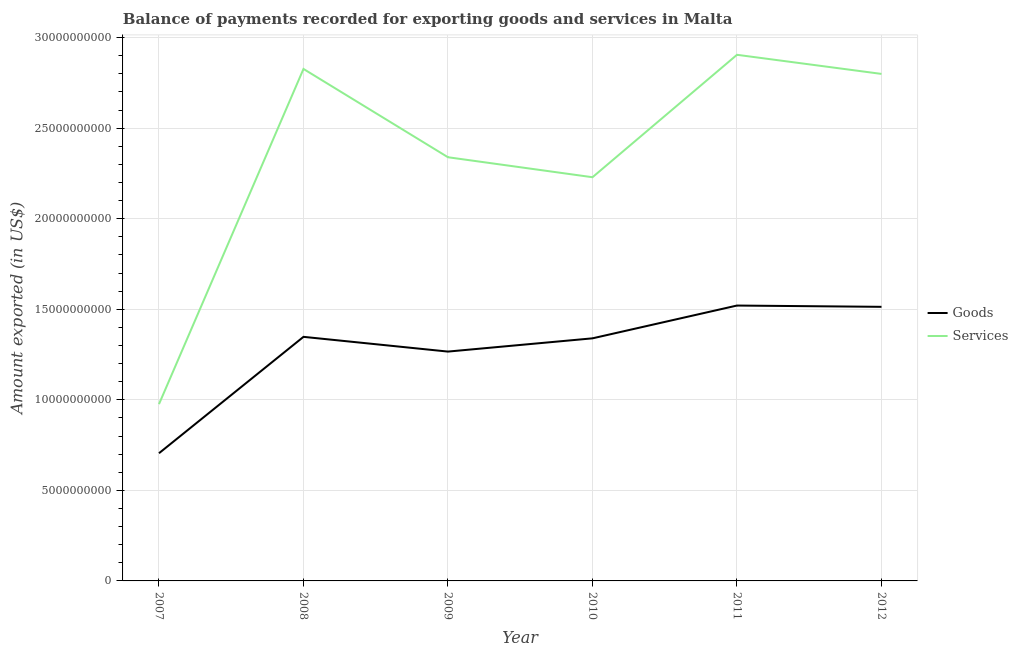Is the number of lines equal to the number of legend labels?
Offer a terse response. Yes. What is the amount of goods exported in 2011?
Provide a short and direct response. 1.52e+1. Across all years, what is the maximum amount of services exported?
Provide a short and direct response. 2.91e+1. Across all years, what is the minimum amount of services exported?
Make the answer very short. 9.76e+09. In which year was the amount of goods exported minimum?
Provide a succinct answer. 2007. What is the total amount of goods exported in the graph?
Provide a short and direct response. 7.69e+1. What is the difference between the amount of goods exported in 2007 and that in 2012?
Keep it short and to the point. -8.08e+09. What is the difference between the amount of services exported in 2012 and the amount of goods exported in 2009?
Offer a terse response. 1.53e+1. What is the average amount of goods exported per year?
Keep it short and to the point. 1.28e+1. In the year 2010, what is the difference between the amount of goods exported and amount of services exported?
Provide a succinct answer. -8.90e+09. What is the ratio of the amount of services exported in 2008 to that in 2010?
Your answer should be compact. 1.27. What is the difference between the highest and the second highest amount of goods exported?
Make the answer very short. 7.08e+07. What is the difference between the highest and the lowest amount of goods exported?
Provide a succinct answer. 8.16e+09. In how many years, is the amount of goods exported greater than the average amount of goods exported taken over all years?
Offer a very short reply. 4. Is the sum of the amount of goods exported in 2008 and 2010 greater than the maximum amount of services exported across all years?
Give a very brief answer. No. Does the amount of services exported monotonically increase over the years?
Offer a very short reply. No. How many lines are there?
Provide a succinct answer. 2. What is the difference between two consecutive major ticks on the Y-axis?
Your answer should be very brief. 5.00e+09. Does the graph contain grids?
Ensure brevity in your answer.  Yes. How many legend labels are there?
Make the answer very short. 2. How are the legend labels stacked?
Your answer should be compact. Vertical. What is the title of the graph?
Ensure brevity in your answer.  Balance of payments recorded for exporting goods and services in Malta. Does "External balance on goods" appear as one of the legend labels in the graph?
Provide a succinct answer. No. What is the label or title of the X-axis?
Provide a short and direct response. Year. What is the label or title of the Y-axis?
Keep it short and to the point. Amount exported (in US$). What is the Amount exported (in US$) in Goods in 2007?
Your response must be concise. 7.05e+09. What is the Amount exported (in US$) of Services in 2007?
Offer a very short reply. 9.76e+09. What is the Amount exported (in US$) of Goods in 2008?
Make the answer very short. 1.35e+1. What is the Amount exported (in US$) of Services in 2008?
Offer a very short reply. 2.83e+1. What is the Amount exported (in US$) in Goods in 2009?
Offer a very short reply. 1.27e+1. What is the Amount exported (in US$) in Services in 2009?
Your answer should be very brief. 2.34e+1. What is the Amount exported (in US$) of Goods in 2010?
Provide a short and direct response. 1.34e+1. What is the Amount exported (in US$) of Services in 2010?
Offer a terse response. 2.23e+1. What is the Amount exported (in US$) of Goods in 2011?
Offer a terse response. 1.52e+1. What is the Amount exported (in US$) in Services in 2011?
Provide a succinct answer. 2.91e+1. What is the Amount exported (in US$) of Goods in 2012?
Provide a short and direct response. 1.51e+1. What is the Amount exported (in US$) in Services in 2012?
Keep it short and to the point. 2.80e+1. Across all years, what is the maximum Amount exported (in US$) in Goods?
Make the answer very short. 1.52e+1. Across all years, what is the maximum Amount exported (in US$) in Services?
Provide a succinct answer. 2.91e+1. Across all years, what is the minimum Amount exported (in US$) of Goods?
Provide a succinct answer. 7.05e+09. Across all years, what is the minimum Amount exported (in US$) in Services?
Your response must be concise. 9.76e+09. What is the total Amount exported (in US$) of Goods in the graph?
Offer a terse response. 7.69e+1. What is the total Amount exported (in US$) in Services in the graph?
Make the answer very short. 1.41e+11. What is the difference between the Amount exported (in US$) in Goods in 2007 and that in 2008?
Offer a very short reply. -6.43e+09. What is the difference between the Amount exported (in US$) of Services in 2007 and that in 2008?
Keep it short and to the point. -1.85e+1. What is the difference between the Amount exported (in US$) in Goods in 2007 and that in 2009?
Your answer should be very brief. -5.61e+09. What is the difference between the Amount exported (in US$) in Services in 2007 and that in 2009?
Offer a very short reply. -1.36e+1. What is the difference between the Amount exported (in US$) in Goods in 2007 and that in 2010?
Keep it short and to the point. -6.34e+09. What is the difference between the Amount exported (in US$) of Services in 2007 and that in 2010?
Offer a very short reply. -1.25e+1. What is the difference between the Amount exported (in US$) of Goods in 2007 and that in 2011?
Your answer should be compact. -8.16e+09. What is the difference between the Amount exported (in US$) in Services in 2007 and that in 2011?
Offer a terse response. -1.93e+1. What is the difference between the Amount exported (in US$) of Goods in 2007 and that in 2012?
Ensure brevity in your answer.  -8.08e+09. What is the difference between the Amount exported (in US$) in Services in 2007 and that in 2012?
Provide a succinct answer. -1.82e+1. What is the difference between the Amount exported (in US$) of Goods in 2008 and that in 2009?
Give a very brief answer. 8.14e+08. What is the difference between the Amount exported (in US$) of Services in 2008 and that in 2009?
Your response must be concise. 4.88e+09. What is the difference between the Amount exported (in US$) in Goods in 2008 and that in 2010?
Your answer should be very brief. 8.22e+07. What is the difference between the Amount exported (in US$) of Services in 2008 and that in 2010?
Offer a terse response. 5.98e+09. What is the difference between the Amount exported (in US$) in Goods in 2008 and that in 2011?
Make the answer very short. -1.73e+09. What is the difference between the Amount exported (in US$) in Services in 2008 and that in 2011?
Offer a terse response. -7.81e+08. What is the difference between the Amount exported (in US$) in Goods in 2008 and that in 2012?
Offer a terse response. -1.66e+09. What is the difference between the Amount exported (in US$) of Services in 2008 and that in 2012?
Ensure brevity in your answer.  2.75e+08. What is the difference between the Amount exported (in US$) of Goods in 2009 and that in 2010?
Offer a very short reply. -7.32e+08. What is the difference between the Amount exported (in US$) of Services in 2009 and that in 2010?
Make the answer very short. 1.10e+09. What is the difference between the Amount exported (in US$) in Goods in 2009 and that in 2011?
Your answer should be very brief. -2.54e+09. What is the difference between the Amount exported (in US$) in Services in 2009 and that in 2011?
Ensure brevity in your answer.  -5.66e+09. What is the difference between the Amount exported (in US$) in Goods in 2009 and that in 2012?
Provide a succinct answer. -2.47e+09. What is the difference between the Amount exported (in US$) of Services in 2009 and that in 2012?
Give a very brief answer. -4.60e+09. What is the difference between the Amount exported (in US$) of Goods in 2010 and that in 2011?
Provide a short and direct response. -1.81e+09. What is the difference between the Amount exported (in US$) in Services in 2010 and that in 2011?
Ensure brevity in your answer.  -6.76e+09. What is the difference between the Amount exported (in US$) of Goods in 2010 and that in 2012?
Your answer should be very brief. -1.74e+09. What is the difference between the Amount exported (in US$) of Services in 2010 and that in 2012?
Your answer should be compact. -5.71e+09. What is the difference between the Amount exported (in US$) in Goods in 2011 and that in 2012?
Offer a terse response. 7.08e+07. What is the difference between the Amount exported (in US$) in Services in 2011 and that in 2012?
Offer a terse response. 1.06e+09. What is the difference between the Amount exported (in US$) in Goods in 2007 and the Amount exported (in US$) in Services in 2008?
Give a very brief answer. -2.12e+1. What is the difference between the Amount exported (in US$) of Goods in 2007 and the Amount exported (in US$) of Services in 2009?
Your answer should be very brief. -1.63e+1. What is the difference between the Amount exported (in US$) of Goods in 2007 and the Amount exported (in US$) of Services in 2010?
Give a very brief answer. -1.52e+1. What is the difference between the Amount exported (in US$) in Goods in 2007 and the Amount exported (in US$) in Services in 2011?
Give a very brief answer. -2.20e+1. What is the difference between the Amount exported (in US$) in Goods in 2007 and the Amount exported (in US$) in Services in 2012?
Make the answer very short. -2.09e+1. What is the difference between the Amount exported (in US$) of Goods in 2008 and the Amount exported (in US$) of Services in 2009?
Offer a terse response. -9.92e+09. What is the difference between the Amount exported (in US$) of Goods in 2008 and the Amount exported (in US$) of Services in 2010?
Make the answer very short. -8.81e+09. What is the difference between the Amount exported (in US$) in Goods in 2008 and the Amount exported (in US$) in Services in 2011?
Give a very brief answer. -1.56e+1. What is the difference between the Amount exported (in US$) in Goods in 2008 and the Amount exported (in US$) in Services in 2012?
Offer a very short reply. -1.45e+1. What is the difference between the Amount exported (in US$) in Goods in 2009 and the Amount exported (in US$) in Services in 2010?
Make the answer very short. -9.63e+09. What is the difference between the Amount exported (in US$) of Goods in 2009 and the Amount exported (in US$) of Services in 2011?
Make the answer very short. -1.64e+1. What is the difference between the Amount exported (in US$) in Goods in 2009 and the Amount exported (in US$) in Services in 2012?
Keep it short and to the point. -1.53e+1. What is the difference between the Amount exported (in US$) in Goods in 2010 and the Amount exported (in US$) in Services in 2011?
Make the answer very short. -1.57e+1. What is the difference between the Amount exported (in US$) in Goods in 2010 and the Amount exported (in US$) in Services in 2012?
Your response must be concise. -1.46e+1. What is the difference between the Amount exported (in US$) in Goods in 2011 and the Amount exported (in US$) in Services in 2012?
Keep it short and to the point. -1.28e+1. What is the average Amount exported (in US$) in Goods per year?
Make the answer very short. 1.28e+1. What is the average Amount exported (in US$) in Services per year?
Offer a terse response. 2.35e+1. In the year 2007, what is the difference between the Amount exported (in US$) in Goods and Amount exported (in US$) in Services?
Provide a short and direct response. -2.71e+09. In the year 2008, what is the difference between the Amount exported (in US$) of Goods and Amount exported (in US$) of Services?
Your answer should be compact. -1.48e+1. In the year 2009, what is the difference between the Amount exported (in US$) of Goods and Amount exported (in US$) of Services?
Offer a terse response. -1.07e+1. In the year 2010, what is the difference between the Amount exported (in US$) of Goods and Amount exported (in US$) of Services?
Offer a very short reply. -8.90e+09. In the year 2011, what is the difference between the Amount exported (in US$) of Goods and Amount exported (in US$) of Services?
Offer a very short reply. -1.38e+1. In the year 2012, what is the difference between the Amount exported (in US$) in Goods and Amount exported (in US$) in Services?
Make the answer very short. -1.29e+1. What is the ratio of the Amount exported (in US$) in Goods in 2007 to that in 2008?
Your response must be concise. 0.52. What is the ratio of the Amount exported (in US$) in Services in 2007 to that in 2008?
Keep it short and to the point. 0.35. What is the ratio of the Amount exported (in US$) in Goods in 2007 to that in 2009?
Your response must be concise. 0.56. What is the ratio of the Amount exported (in US$) of Services in 2007 to that in 2009?
Provide a succinct answer. 0.42. What is the ratio of the Amount exported (in US$) in Goods in 2007 to that in 2010?
Offer a very short reply. 0.53. What is the ratio of the Amount exported (in US$) in Services in 2007 to that in 2010?
Your answer should be compact. 0.44. What is the ratio of the Amount exported (in US$) in Goods in 2007 to that in 2011?
Your answer should be very brief. 0.46. What is the ratio of the Amount exported (in US$) of Services in 2007 to that in 2011?
Provide a short and direct response. 0.34. What is the ratio of the Amount exported (in US$) in Goods in 2007 to that in 2012?
Ensure brevity in your answer.  0.47. What is the ratio of the Amount exported (in US$) in Services in 2007 to that in 2012?
Keep it short and to the point. 0.35. What is the ratio of the Amount exported (in US$) of Goods in 2008 to that in 2009?
Your answer should be very brief. 1.06. What is the ratio of the Amount exported (in US$) in Services in 2008 to that in 2009?
Make the answer very short. 1.21. What is the ratio of the Amount exported (in US$) in Goods in 2008 to that in 2010?
Keep it short and to the point. 1.01. What is the ratio of the Amount exported (in US$) of Services in 2008 to that in 2010?
Offer a terse response. 1.27. What is the ratio of the Amount exported (in US$) of Goods in 2008 to that in 2011?
Make the answer very short. 0.89. What is the ratio of the Amount exported (in US$) in Services in 2008 to that in 2011?
Offer a very short reply. 0.97. What is the ratio of the Amount exported (in US$) in Goods in 2008 to that in 2012?
Your answer should be very brief. 0.89. What is the ratio of the Amount exported (in US$) of Services in 2008 to that in 2012?
Your answer should be very brief. 1.01. What is the ratio of the Amount exported (in US$) of Goods in 2009 to that in 2010?
Give a very brief answer. 0.95. What is the ratio of the Amount exported (in US$) in Services in 2009 to that in 2010?
Offer a terse response. 1.05. What is the ratio of the Amount exported (in US$) of Goods in 2009 to that in 2011?
Your answer should be compact. 0.83. What is the ratio of the Amount exported (in US$) of Services in 2009 to that in 2011?
Your response must be concise. 0.81. What is the ratio of the Amount exported (in US$) of Goods in 2009 to that in 2012?
Offer a very short reply. 0.84. What is the ratio of the Amount exported (in US$) in Services in 2009 to that in 2012?
Give a very brief answer. 0.84. What is the ratio of the Amount exported (in US$) of Goods in 2010 to that in 2011?
Your answer should be compact. 0.88. What is the ratio of the Amount exported (in US$) of Services in 2010 to that in 2011?
Keep it short and to the point. 0.77. What is the ratio of the Amount exported (in US$) in Goods in 2010 to that in 2012?
Provide a succinct answer. 0.89. What is the ratio of the Amount exported (in US$) in Services in 2010 to that in 2012?
Provide a short and direct response. 0.8. What is the ratio of the Amount exported (in US$) in Services in 2011 to that in 2012?
Your answer should be compact. 1.04. What is the difference between the highest and the second highest Amount exported (in US$) in Goods?
Your response must be concise. 7.08e+07. What is the difference between the highest and the second highest Amount exported (in US$) in Services?
Ensure brevity in your answer.  7.81e+08. What is the difference between the highest and the lowest Amount exported (in US$) of Goods?
Your answer should be very brief. 8.16e+09. What is the difference between the highest and the lowest Amount exported (in US$) in Services?
Offer a terse response. 1.93e+1. 